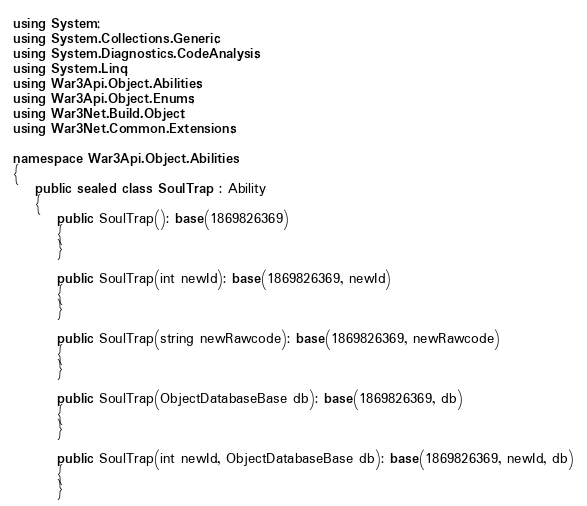<code> <loc_0><loc_0><loc_500><loc_500><_C#_>using System;
using System.Collections.Generic;
using System.Diagnostics.CodeAnalysis;
using System.Linq;
using War3Api.Object.Abilities;
using War3Api.Object.Enums;
using War3Net.Build.Object;
using War3Net.Common.Extensions;

namespace War3Api.Object.Abilities
{
    public sealed class SoulTrap : Ability
    {
        public SoulTrap(): base(1869826369)
        {
        }

        public SoulTrap(int newId): base(1869826369, newId)
        {
        }

        public SoulTrap(string newRawcode): base(1869826369, newRawcode)
        {
        }

        public SoulTrap(ObjectDatabaseBase db): base(1869826369, db)
        {
        }

        public SoulTrap(int newId, ObjectDatabaseBase db): base(1869826369, newId, db)
        {
        }
</code> 